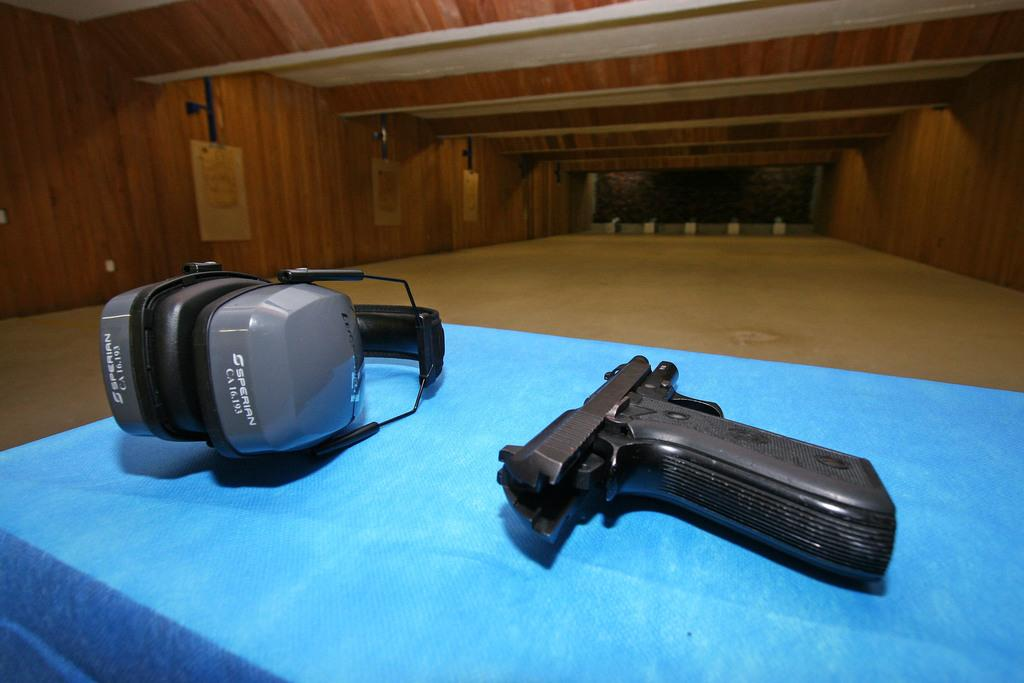What object is located on the right side of the image? There is a gun on the right side of the image. What can be seen on the left side of the image? There is a headset on the left side of the image. What is the color and type of object in the middle of the image? There is a blue color cloth in the middle of the image. How many teeth can be seen on the drum in the image? There is no drum or teeth present in the image. What type of bit is attached to the cloth in the image? There is no bit attached to the cloth in the image; it is just a blue color cloth. 